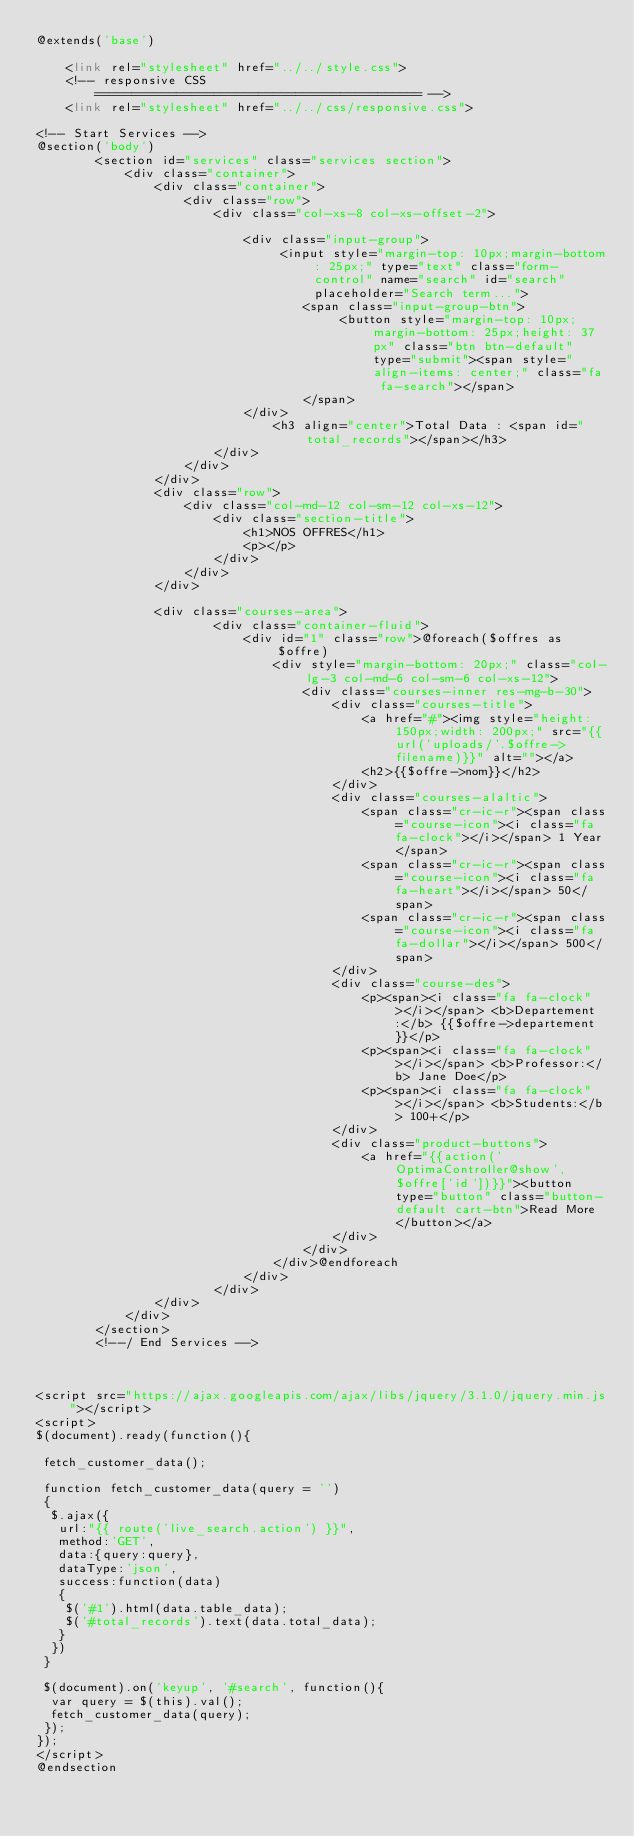<code> <loc_0><loc_0><loc_500><loc_500><_PHP_>@extends('base')

    <link rel="stylesheet" href="../../style.css">
    <!-- responsive CSS
		============================================ -->
    <link rel="stylesheet" href="../../css/responsive.css">
 
<!-- Start Services -->
@section('body')
		<section id="services" class="services section">
			<div class="container">
				<div class="container"> 
   					<div class="row">  
   						<div class="col-xs-8 col-xs-offset-2"> 
   							
      						<div class="input-group"> 
      							 <input style="margin-top: 10px;margin-bottom: 25px;" type="text" class="form-control" name="search" id="search" placeholder="Search term..."> 
      								<span class="input-group-btn"> 
       									 <button style="margin-top: 10px;margin-bottom: 25px;height: 37px" class="btn btn-default" type="submit"><span style="align-items: center;" class="fa fa-search"></span>
      								</span> 
      						</div>
      							<h3 align="center">Total Data : <span id="total_records"></span></h3>
      					</div> 
   					</div> 
				</div>  
				<div class="row">
					<div class="col-md-12 col-sm-12 col-xs-12">
						<div class="section-title">
							<h1>NOS OFFRES</h1>
							<p></p>
						</div>
					</div>
				</div>

				<div class="courses-area">
			            <div class="container-fluid">
			                <div id="1" class="row">@foreach($offres as $offre)
			                    <div style="margin-bottom: 20px;" class="col-lg-3 col-md-6 col-sm-6 col-xs-12">
			                        <div class="courses-inner res-mg-b-30">
			                            <div class="courses-title">
			                                <a href="#"><img style="height: 150px;width: 200px;" src="{{url('uploads/'.$offre->filename)}}" alt=""></a>
			                                <h2>{{$offre->nom}}</h2>
			                            </div>
			                            <div class="courses-alaltic">
			                                <span class="cr-ic-r"><span class="course-icon"><i class="fa fa-clock"></i></span> 1 Year</span>
			                                <span class="cr-ic-r"><span class="course-icon"><i class="fa fa-heart"></i></span> 50</span>
			                                <span class="cr-ic-r"><span class="course-icon"><i class="fa fa-dollar"></i></span> 500</span>
			                            </div>
			                            <div class="course-des">
			                                <p><span><i class="fa fa-clock"></i></span> <b>Departement:</b> {{$offre->departement}}</p>
			                                <p><span><i class="fa fa-clock"></i></span> <b>Professor:</b> Jane Doe</p>
			                                <p><span><i class="fa fa-clock"></i></span> <b>Students:</b> 100+</p>
			                            </div>
			                            <div class="product-buttons">
			                                <a href="{{action('OptimaController@show', $offre['id'])}}"><button type="button" class="button-default cart-btn">Read More</button></a>
			                            </div>
			                        </div>
			                    </div>@endforeach
							</div>
						</div>
				</div>
			</div>
		</section>
		<!--/ End Services -->



<script src="https://ajax.googleapis.com/ajax/libs/jquery/3.1.0/jquery.min.js"></script>
<script>
$(document).ready(function(){

 fetch_customer_data();

 function fetch_customer_data(query = '')
 {
  $.ajax({
   url:"{{ route('live_search.action') }}",
   method:'GET',
   data:{query:query},
   dataType:'json',
   success:function(data)
   {
    $('#1').html(data.table_data);
    $('#total_records').text(data.total_data);
   }
  })
 }

 $(document).on('keyup', '#search', function(){
  var query = $(this).val();
  fetch_customer_data(query);
 });
});
</script>
@endsection</code> 